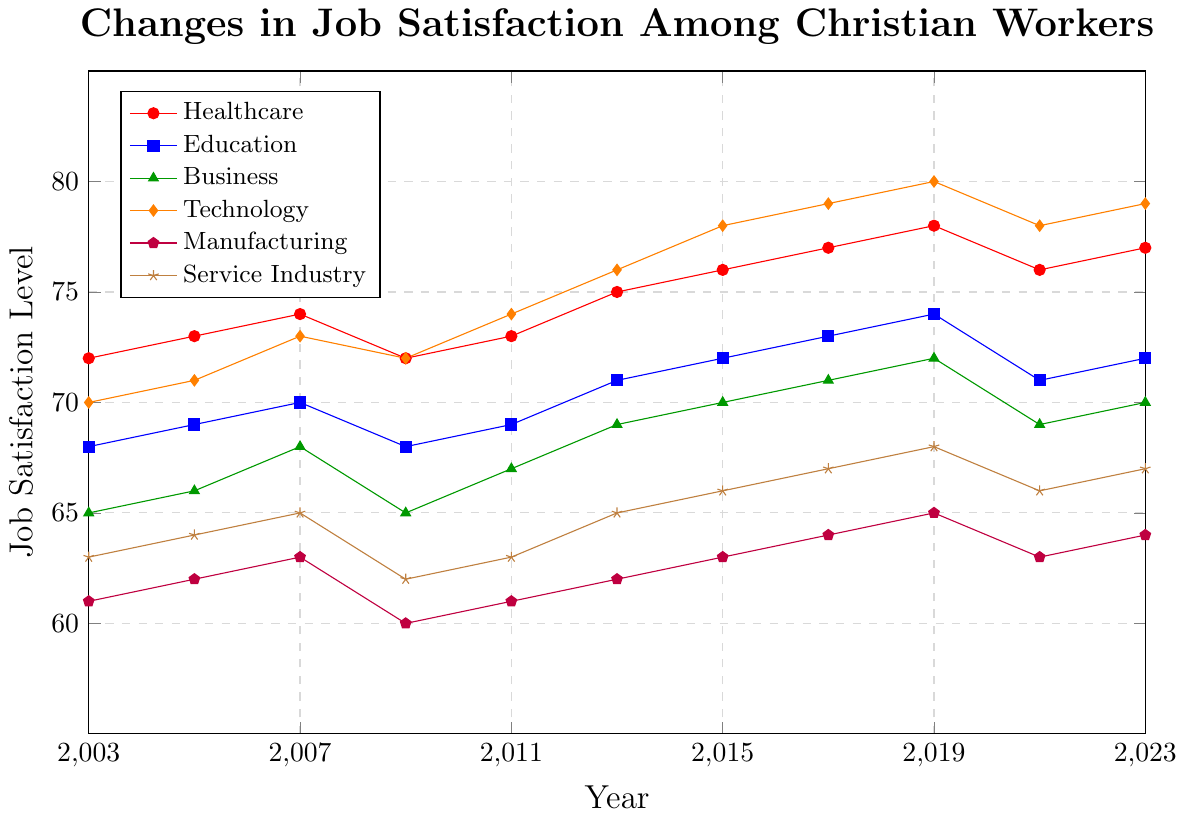What's the trend in job satisfaction levels in the Technology industry from 2003 to 2023? Look at the line representing Technology (orange with diamonds). Identify the values from 2003 (70) through 2023 (79) and note the upward trend with a peak in 2019 (80) and slight fluctuations.
Answer: Increasing trend Which industry had the lowest job satisfaction in 2009, and what was the level? Examine all the lines in 2009 and identify the lowest point. The Manufacturing industry (purple with pentagons) had the lowest level at 60.
Answer: Manufacturing, 60 For the year 2019, which industry reported the highest job satisfaction and which reported the lowest? Identify the 2019 data points across all lines. Technology (orange with diamonds) has the highest level at 80, and Manufacturing (purple with pentagons) has the lowest at 65.
Answer: Technology, Manufacturing What is the average job satisfaction level in Education from 2003 to 2023? Sum the satisfaction levels for Education (2003: 68, 2005: 69, 2007: 70, 2009: 68, 2011: 69, 2013: 71, 2015: 72, 2017: 73, 2019: 74, 2021: 71, 2023: 72) and divide by the total number of years (11). (68+69+70+68+69+71+72+73+74+71+72) = 777, and 777 / 11 = 70.64.
Answer: 70.64 Compare the job satisfaction trends in Healthcare and Service Industry between 2007 and 2013. Look at the lines for Healthcare (red with circles) and Service Industry (brown with stars) from 2007 to 2013. Healthcare increased from 74 to 75, while Service Industry increased from 65 to 65. Both industries show slight increases.
Answer: Both increasing, Healthcare slightly higher Did job satisfaction in the Manufacturing industry ever surpass 65 between 2003 and 2023? If so, when? Follow the purple pentagon line for Manufacturing. It surpasses 65 only in 2019, reaching exactly 65.
Answer: Yes, in 2019 In which years did all industries report job satisfaction levels above 65? Check for all points across all industries where values are above 65. This was only achieved in 2019 and 2023.
Answer: 2019, 2023 What is the range of job satisfaction levels in the Business industry over the past two decades? Identify the highest and lowest points for Business (green with triangles) from 2003 (65) and 2023 (70), respectively. The range is 70 - 65 = 5.
Answer: 5 Which industry saw the most significant average increase in job satisfaction from 2003 to 2023? Calculate the average increase for each industry by finding the difference between 2023 and 2003 data points and dividing by the number of years (20). Technology increased from 70 to 79, an increase of 9, the highest among the industries.
Answer: Technology 